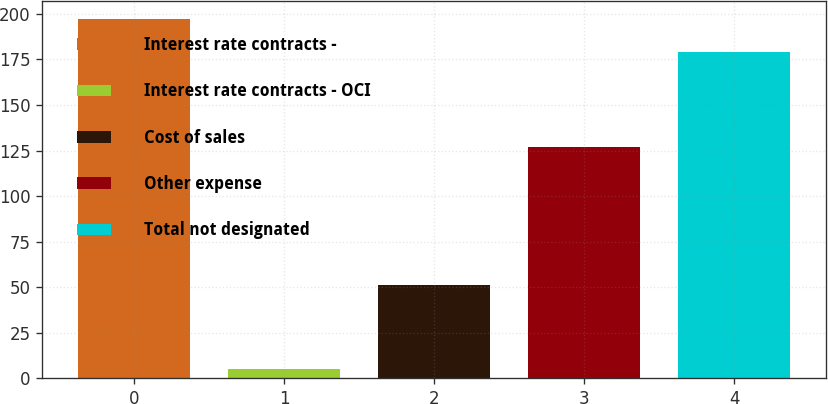<chart> <loc_0><loc_0><loc_500><loc_500><bar_chart><fcel>Interest rate contracts -<fcel>Interest rate contracts - OCI<fcel>Cost of sales<fcel>Other expense<fcel>Total not designated<nl><fcel>197.3<fcel>5<fcel>51<fcel>127<fcel>179<nl></chart> 